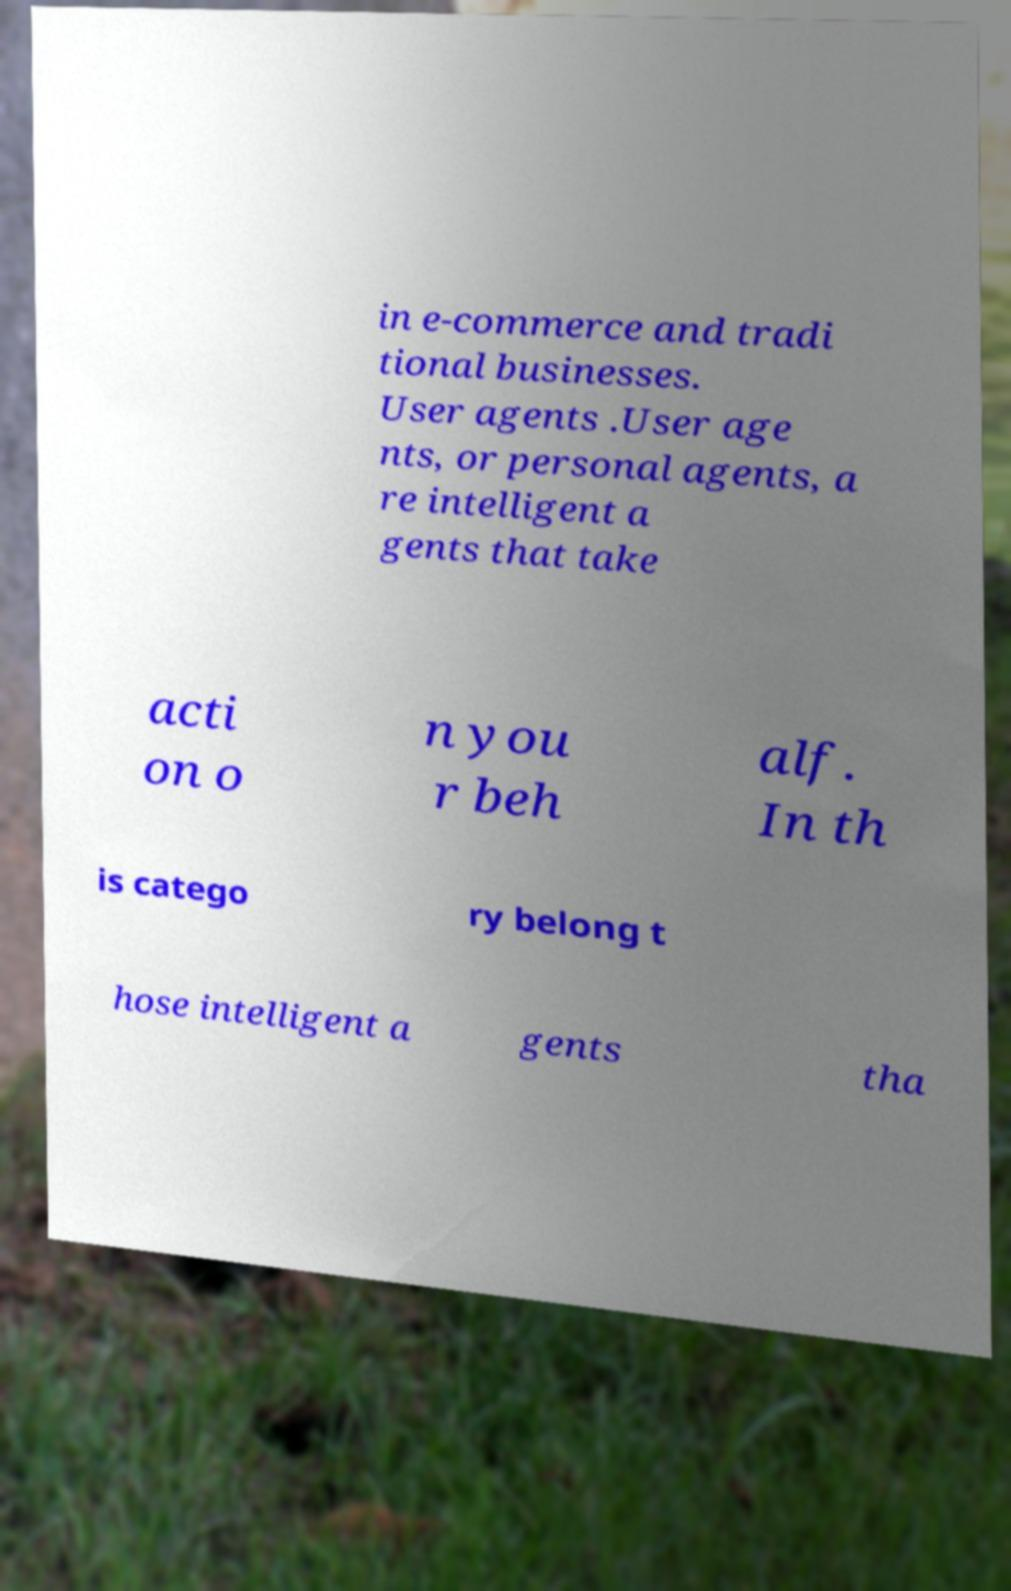Could you assist in decoding the text presented in this image and type it out clearly? in e-commerce and tradi tional businesses. User agents .User age nts, or personal agents, a re intelligent a gents that take acti on o n you r beh alf. In th is catego ry belong t hose intelligent a gents tha 